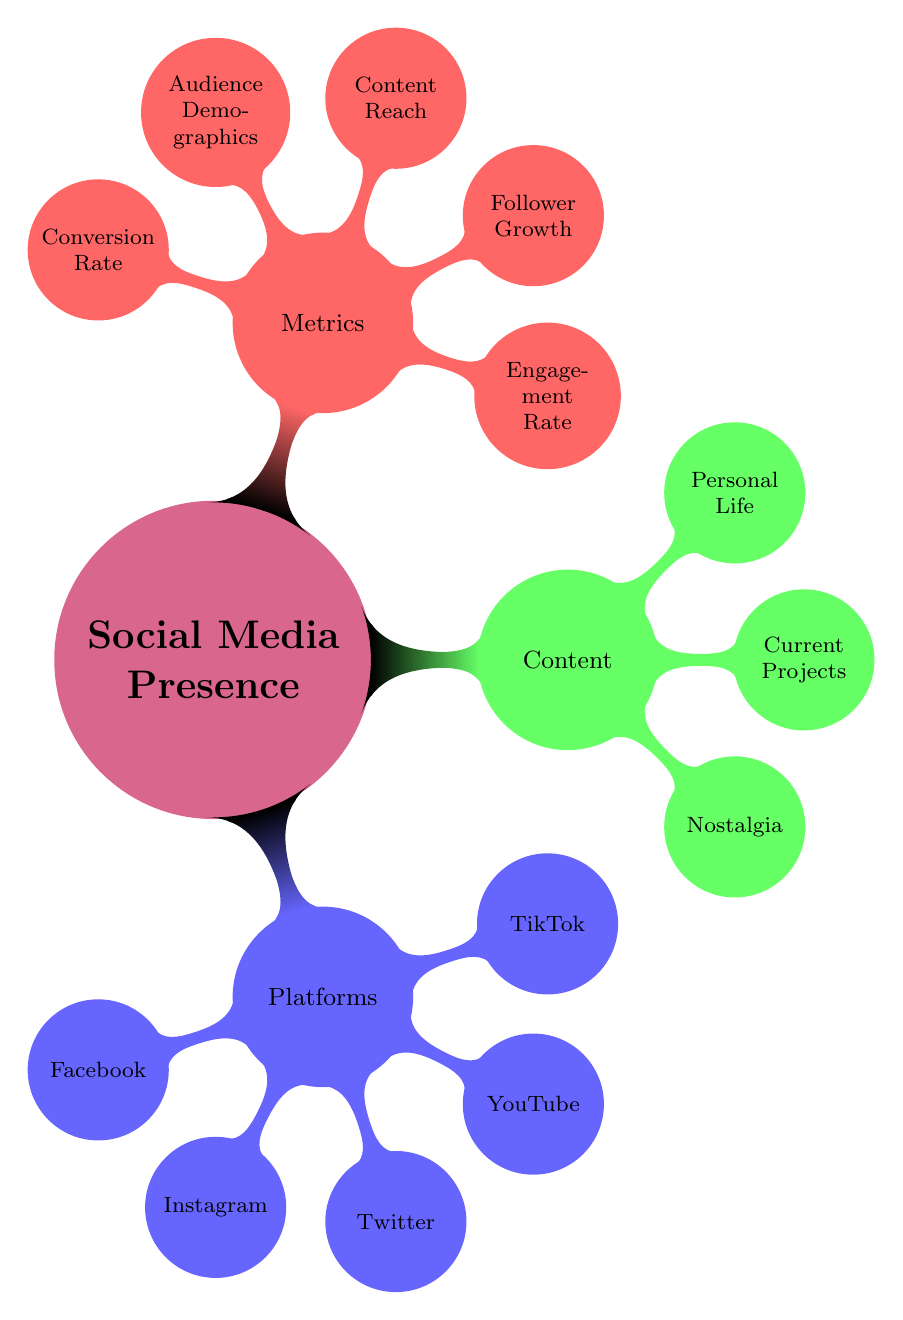What are the five platforms mentioned in the diagram? The diagram lists the platforms under the "Platforms" node. By counting the child nodes under that section, we can identify that there are five platforms: Facebook, Instagram, Twitter, YouTube, and TikTok.
Answer: Facebook, Instagram, Twitter, YouTube, TikTok What type of content is associated with Instagram? Looking at the "Content Type" that branches off from the Instagram node, it specifies that the content type includes daily stories, reels, and collaborations with influencers.
Answer: Daily Stories, Reels, Collaborations with Influencers What is the purpose of Facebook in this plan? To determine Facebook's purpose, we look at the node under Facebook. It states clearly that the purpose is to reconnect with loyal fans and share nostalgic content.
Answer: Reconnect with loyal fans and share nostalgic content How many metrics are indicated in the diagram? The "Metrics" node lists five distinct categories, which means we can count these to find out how many metrics are present overall. They include engagement rate, follower growth, content reach, audience demographics, and conversion rate.
Answer: Five Which content type focuses on personal life? Under the "Content" category, there is a section detailing personal life. By examining this section, it becomes clear that it consists of daily routines, hobbies, and family moments.
Answer: Daily Routines, Hobbies, Family Moments What is the primary content type for TikTok? To find this, we look at the TikTok node under "Platforms" and read the content types listed: short skits, viral challenges, and collaborations with TikTok stars, which provide an overview of what is emphasized on this platform.
Answer: Short Skits, Viral Challenges, Collaborations with TikTok Stars What metric relates to audience insights? In the "Metrics" section, we identify that "Audience Demographics" caters to insights about the audience, covering aspects such as age, gender, and location, thus, it is the metric responsible for audience insights.
Answer: Audience Demographics How does "Content Reach" measure performance? The "Content Reach" item under the "Metrics" node indicates that performance is measured through views and impressions, therefore, it shows how well the content is spreading and being seen by audiences.
Answer: Views, Impressions What is the purpose of YouTube in the plan? By assessing the "YouTube" node in the diagram, we can easily ascertain that its purpose is to share longer, in-depth video content, which distinguishes it from the other platforms used.
Answer: Share longer, in-depth video content 